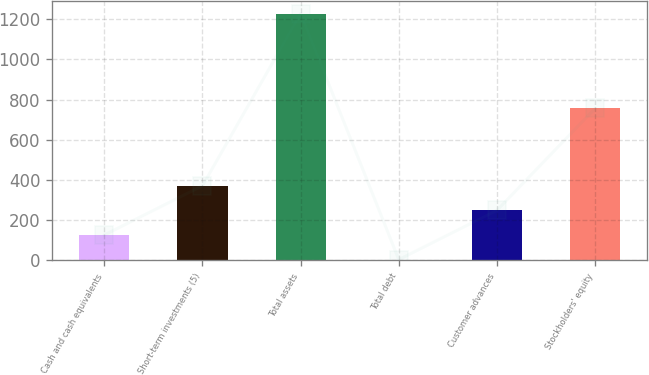Convert chart to OTSL. <chart><loc_0><loc_0><loc_500><loc_500><bar_chart><fcel>Cash and cash equivalents<fcel>Short-term investments (5)<fcel>Total assets<fcel>Total debt<fcel>Customer advances<fcel>Stockholders' equity<nl><fcel>126.59<fcel>371.37<fcel>1228.1<fcel>4.2<fcel>248.98<fcel>755.9<nl></chart> 